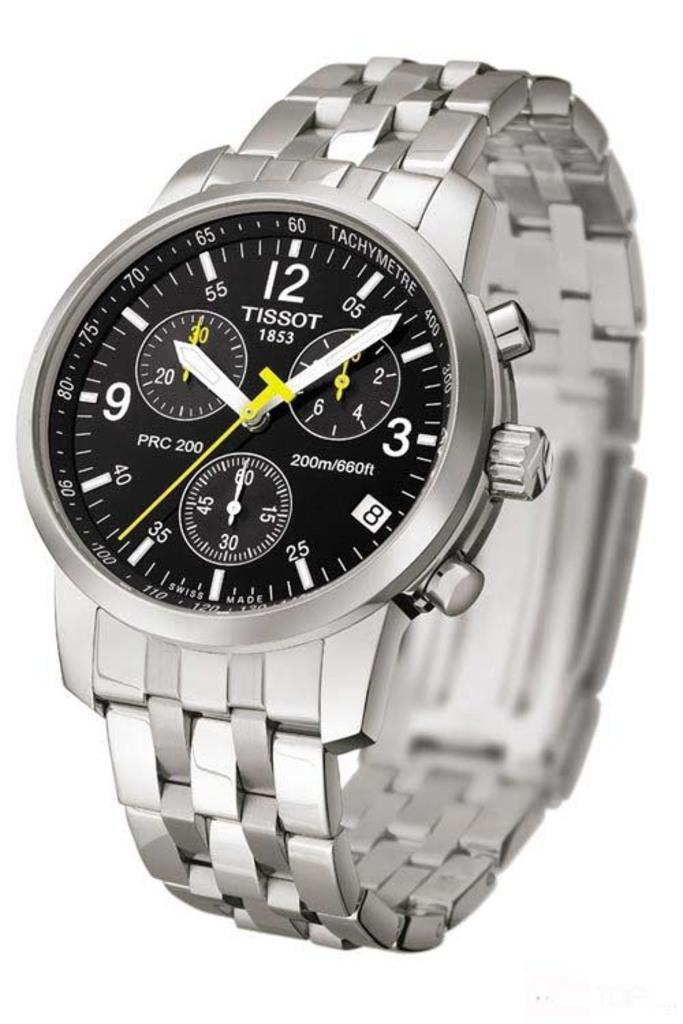<image>
Relay a brief, clear account of the picture shown. a Tissot 1853 analog silver watch with black face 